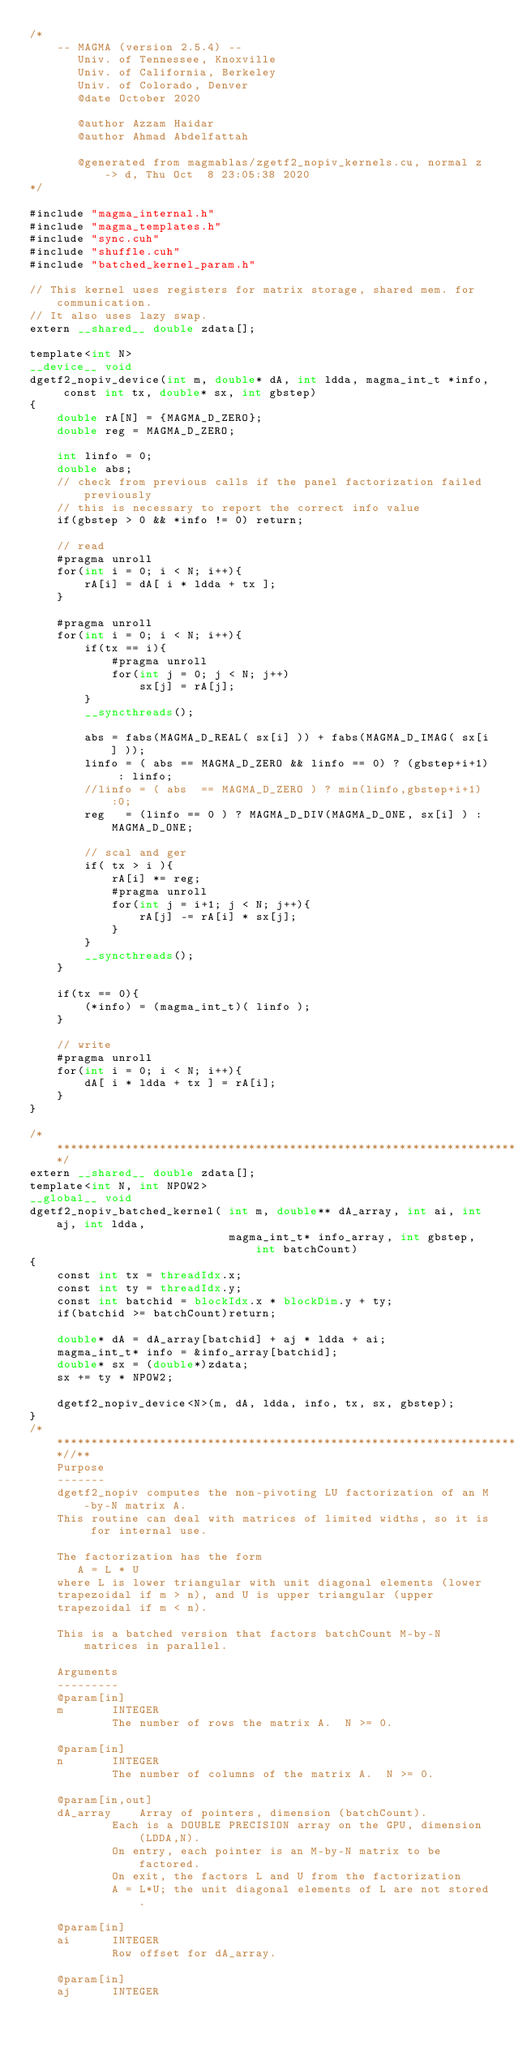<code> <loc_0><loc_0><loc_500><loc_500><_Cuda_>/*
    -- MAGMA (version 2.5.4) --
       Univ. of Tennessee, Knoxville
       Univ. of California, Berkeley
       Univ. of Colorado, Denver
       @date October 2020

       @author Azzam Haidar
       @author Ahmad Abdelfattah

       @generated from magmablas/zgetf2_nopiv_kernels.cu, normal z -> d, Thu Oct  8 23:05:38 2020
*/

#include "magma_internal.h"
#include "magma_templates.h"
#include "sync.cuh"
#include "shuffle.cuh"
#include "batched_kernel_param.h"

// This kernel uses registers for matrix storage, shared mem. for communication.
// It also uses lazy swap.
extern __shared__ double zdata[];

template<int N>
__device__ void
dgetf2_nopiv_device(int m, double* dA, int ldda, magma_int_t *info, const int tx, double* sx, int gbstep)
{
    double rA[N] = {MAGMA_D_ZERO};
    double reg = MAGMA_D_ZERO; 
    
    int linfo = 0;
    double abs;
    // check from previous calls if the panel factorization failed previously
    // this is necessary to report the correct info value 
    if(gbstep > 0 && *info != 0) return;

    // read 
    #pragma unroll
    for(int i = 0; i < N; i++){
        rA[i] = dA[ i * ldda + tx ];
    }
        
    #pragma unroll
    for(int i = 0; i < N; i++){
        if(tx == i){
            #pragma unroll
            for(int j = 0; j < N; j++)
                sx[j] = rA[j];
        }
        __syncthreads();

        abs = fabs(MAGMA_D_REAL( sx[i] )) + fabs(MAGMA_D_IMAG( sx[i] ));
        linfo = ( abs == MAGMA_D_ZERO && linfo == 0) ? (gbstep+i+1) : linfo;
        //linfo = ( abs  == MAGMA_D_ZERO ) ? min(linfo,gbstep+i+1):0;
        reg   = (linfo == 0 ) ? MAGMA_D_DIV(MAGMA_D_ONE, sx[i] ) : MAGMA_D_ONE;

        // scal and ger
        if( tx > i ){
            rA[i] *= reg;
            #pragma unroll
            for(int j = i+1; j < N; j++){
                rA[j] -= rA[i] * sx[j];
            }
        }
        __syncthreads();
    }

    if(tx == 0){
        (*info) = (magma_int_t)( linfo );
    }

    // write
    #pragma unroll
    for(int i = 0; i < N; i++){
        dA[ i * ldda + tx ] = rA[i];
    }
}

/******************************************************************************/
extern __shared__ double zdata[];
template<int N, int NPOW2>
__global__ void
dgetf2_nopiv_batched_kernel( int m, double** dA_array, int ai, int aj, int ldda, 
                             magma_int_t* info_array, int gbstep, int batchCount)
{
    const int tx = threadIdx.x;
    const int ty = threadIdx.y;
    const int batchid = blockIdx.x * blockDim.y + ty;
    if(batchid >= batchCount)return;

    double* dA = dA_array[batchid] + aj * ldda + ai;
    magma_int_t* info = &info_array[batchid];
    double* sx = (double*)zdata;
    sx += ty * NPOW2;

    dgetf2_nopiv_device<N>(m, dA, ldda, info, tx, sx, gbstep);
}
/***************************************************************************//**
    Purpose
    -------
    dgetf2_nopiv computes the non-pivoting LU factorization of an M-by-N matrix A.
    This routine can deal with matrices of limited widths, so it is for internal use.

    The factorization has the form
       A = L * U
    where L is lower triangular with unit diagonal elements (lower
    trapezoidal if m > n), and U is upper triangular (upper
    trapezoidal if m < n).

    This is a batched version that factors batchCount M-by-N matrices in parallel.

    Arguments
    ---------
    @param[in]
    m       INTEGER
            The number of rows the matrix A.  N >= 0.

    @param[in]
    n       INTEGER
            The number of columns of the matrix A.  N >= 0.

    @param[in,out]
    dA_array    Array of pointers, dimension (batchCount).
            Each is a DOUBLE PRECISION array on the GPU, dimension (LDDA,N).
            On entry, each pointer is an M-by-N matrix to be factored.
            On exit, the factors L and U from the factorization
            A = L*U; the unit diagonal elements of L are not stored.

    @param[in]
    ai      INTEGER
            Row offset for dA_array.

    @param[in]
    aj      INTEGER</code> 